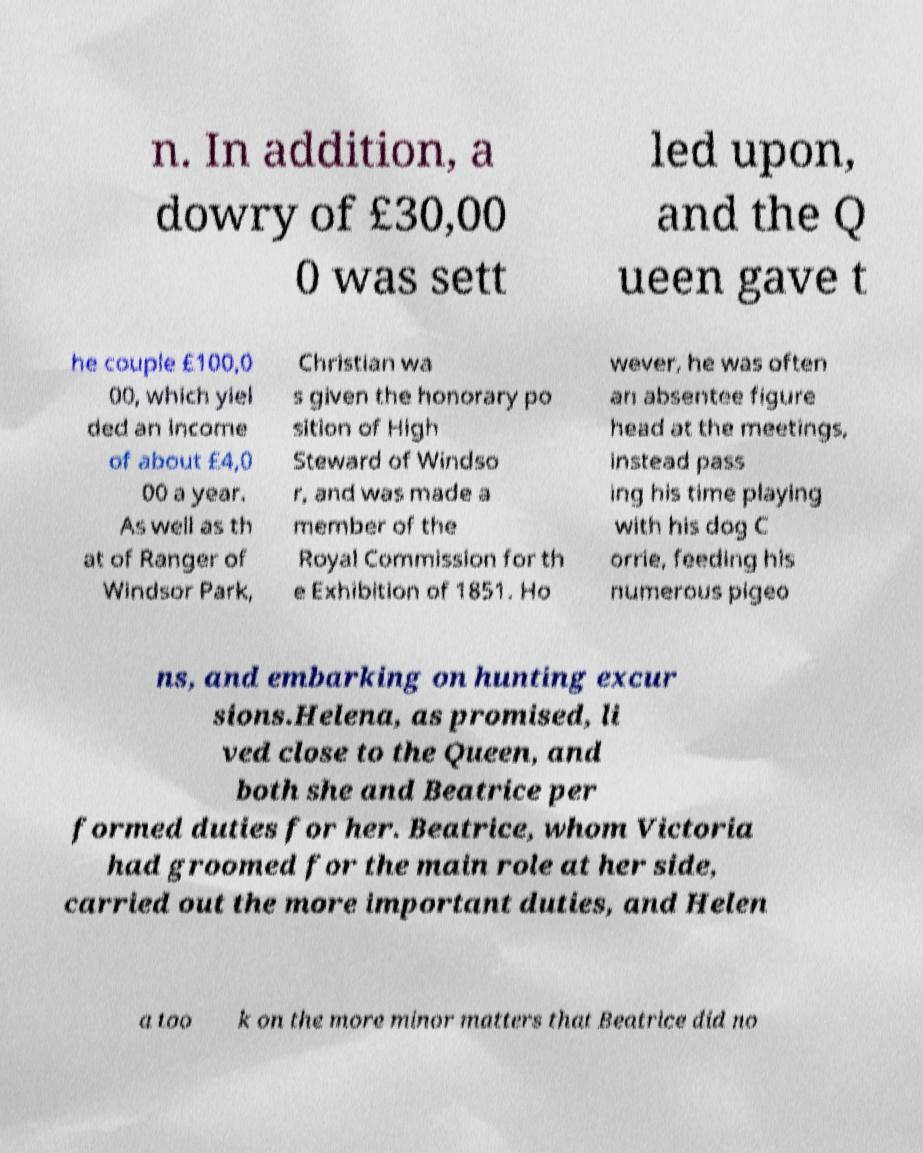There's text embedded in this image that I need extracted. Can you transcribe it verbatim? n. In addition, a dowry of £30,00 0 was sett led upon, and the Q ueen gave t he couple £100,0 00, which yiel ded an income of about £4,0 00 a year. As well as th at of Ranger of Windsor Park, Christian wa s given the honorary po sition of High Steward of Windso r, and was made a member of the Royal Commission for th e Exhibition of 1851. Ho wever, he was often an absentee figure head at the meetings, instead pass ing his time playing with his dog C orrie, feeding his numerous pigeo ns, and embarking on hunting excur sions.Helena, as promised, li ved close to the Queen, and both she and Beatrice per formed duties for her. Beatrice, whom Victoria had groomed for the main role at her side, carried out the more important duties, and Helen a too k on the more minor matters that Beatrice did no 